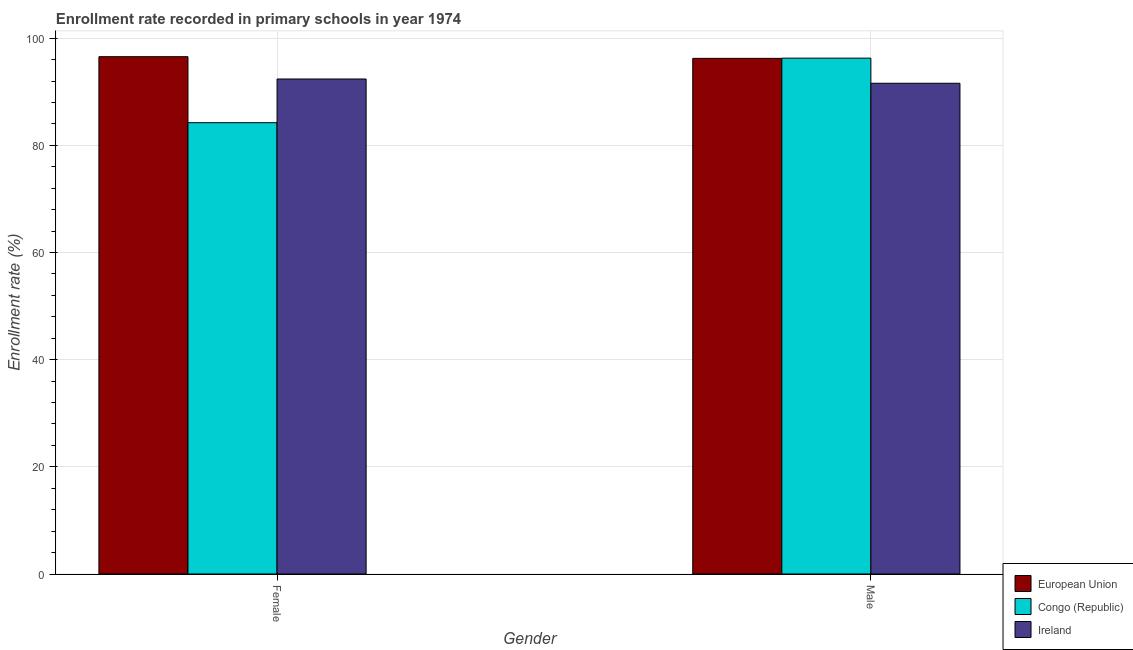Are the number of bars on each tick of the X-axis equal?
Offer a terse response. Yes. How many bars are there on the 1st tick from the left?
Keep it short and to the point. 3. How many bars are there on the 2nd tick from the right?
Give a very brief answer. 3. What is the label of the 2nd group of bars from the left?
Provide a succinct answer. Male. What is the enrollment rate of male students in Ireland?
Make the answer very short. 91.59. Across all countries, what is the maximum enrollment rate of male students?
Ensure brevity in your answer.  96.28. Across all countries, what is the minimum enrollment rate of female students?
Keep it short and to the point. 84.24. In which country was the enrollment rate of female students maximum?
Offer a very short reply. European Union. In which country was the enrollment rate of female students minimum?
Ensure brevity in your answer.  Congo (Republic). What is the total enrollment rate of female students in the graph?
Keep it short and to the point. 273.18. What is the difference between the enrollment rate of female students in Ireland and that in Congo (Republic)?
Your response must be concise. 8.15. What is the difference between the enrollment rate of female students in Ireland and the enrollment rate of male students in European Union?
Provide a succinct answer. -3.85. What is the average enrollment rate of female students per country?
Your answer should be compact. 91.06. What is the difference between the enrollment rate of female students and enrollment rate of male students in Congo (Republic)?
Provide a short and direct response. -12.04. In how many countries, is the enrollment rate of female students greater than 64 %?
Make the answer very short. 3. What is the ratio of the enrollment rate of female students in Ireland to that in European Union?
Provide a short and direct response. 0.96. Is the enrollment rate of female students in Ireland less than that in European Union?
Your answer should be very brief. Yes. What does the 2nd bar from the left in Male represents?
Keep it short and to the point. Congo (Republic). What does the 1st bar from the right in Female represents?
Provide a short and direct response. Ireland. How many bars are there?
Offer a terse response. 6. How many countries are there in the graph?
Your answer should be compact. 3. Are the values on the major ticks of Y-axis written in scientific E-notation?
Your answer should be compact. No. Does the graph contain grids?
Give a very brief answer. Yes. Where does the legend appear in the graph?
Your response must be concise. Bottom right. What is the title of the graph?
Offer a very short reply. Enrollment rate recorded in primary schools in year 1974. What is the label or title of the X-axis?
Offer a very short reply. Gender. What is the label or title of the Y-axis?
Keep it short and to the point. Enrollment rate (%). What is the Enrollment rate (%) in European Union in Female?
Offer a terse response. 96.55. What is the Enrollment rate (%) of Congo (Republic) in Female?
Your answer should be compact. 84.24. What is the Enrollment rate (%) in Ireland in Female?
Provide a short and direct response. 92.39. What is the Enrollment rate (%) of European Union in Male?
Your answer should be compact. 96.24. What is the Enrollment rate (%) of Congo (Republic) in Male?
Provide a short and direct response. 96.28. What is the Enrollment rate (%) in Ireland in Male?
Your answer should be compact. 91.59. Across all Gender, what is the maximum Enrollment rate (%) in European Union?
Provide a succinct answer. 96.55. Across all Gender, what is the maximum Enrollment rate (%) in Congo (Republic)?
Your response must be concise. 96.28. Across all Gender, what is the maximum Enrollment rate (%) in Ireland?
Make the answer very short. 92.39. Across all Gender, what is the minimum Enrollment rate (%) of European Union?
Provide a succinct answer. 96.24. Across all Gender, what is the minimum Enrollment rate (%) in Congo (Republic)?
Offer a terse response. 84.24. Across all Gender, what is the minimum Enrollment rate (%) in Ireland?
Offer a very short reply. 91.59. What is the total Enrollment rate (%) of European Union in the graph?
Ensure brevity in your answer.  192.79. What is the total Enrollment rate (%) of Congo (Republic) in the graph?
Offer a very short reply. 180.52. What is the total Enrollment rate (%) of Ireland in the graph?
Keep it short and to the point. 183.99. What is the difference between the Enrollment rate (%) of European Union in Female and that in Male?
Make the answer very short. 0.31. What is the difference between the Enrollment rate (%) of Congo (Republic) in Female and that in Male?
Offer a terse response. -12.04. What is the difference between the Enrollment rate (%) in Ireland in Female and that in Male?
Your response must be concise. 0.8. What is the difference between the Enrollment rate (%) in European Union in Female and the Enrollment rate (%) in Congo (Republic) in Male?
Give a very brief answer. 0.27. What is the difference between the Enrollment rate (%) in European Union in Female and the Enrollment rate (%) in Ireland in Male?
Your answer should be compact. 4.96. What is the difference between the Enrollment rate (%) of Congo (Republic) in Female and the Enrollment rate (%) of Ireland in Male?
Offer a very short reply. -7.36. What is the average Enrollment rate (%) of European Union per Gender?
Offer a terse response. 96.4. What is the average Enrollment rate (%) in Congo (Republic) per Gender?
Keep it short and to the point. 90.26. What is the average Enrollment rate (%) in Ireland per Gender?
Keep it short and to the point. 91.99. What is the difference between the Enrollment rate (%) of European Union and Enrollment rate (%) of Congo (Republic) in Female?
Ensure brevity in your answer.  12.32. What is the difference between the Enrollment rate (%) in European Union and Enrollment rate (%) in Ireland in Female?
Keep it short and to the point. 4.16. What is the difference between the Enrollment rate (%) of Congo (Republic) and Enrollment rate (%) of Ireland in Female?
Offer a terse response. -8.15. What is the difference between the Enrollment rate (%) of European Union and Enrollment rate (%) of Congo (Republic) in Male?
Your answer should be compact. -0.04. What is the difference between the Enrollment rate (%) in European Union and Enrollment rate (%) in Ireland in Male?
Provide a succinct answer. 4.65. What is the difference between the Enrollment rate (%) of Congo (Republic) and Enrollment rate (%) of Ireland in Male?
Your response must be concise. 4.69. What is the ratio of the Enrollment rate (%) in European Union in Female to that in Male?
Offer a very short reply. 1. What is the ratio of the Enrollment rate (%) in Congo (Republic) in Female to that in Male?
Make the answer very short. 0.87. What is the ratio of the Enrollment rate (%) in Ireland in Female to that in Male?
Offer a terse response. 1.01. What is the difference between the highest and the second highest Enrollment rate (%) in European Union?
Keep it short and to the point. 0.31. What is the difference between the highest and the second highest Enrollment rate (%) in Congo (Republic)?
Offer a terse response. 12.04. What is the difference between the highest and the second highest Enrollment rate (%) in Ireland?
Your answer should be compact. 0.8. What is the difference between the highest and the lowest Enrollment rate (%) of European Union?
Offer a very short reply. 0.31. What is the difference between the highest and the lowest Enrollment rate (%) of Congo (Republic)?
Make the answer very short. 12.04. What is the difference between the highest and the lowest Enrollment rate (%) in Ireland?
Give a very brief answer. 0.8. 